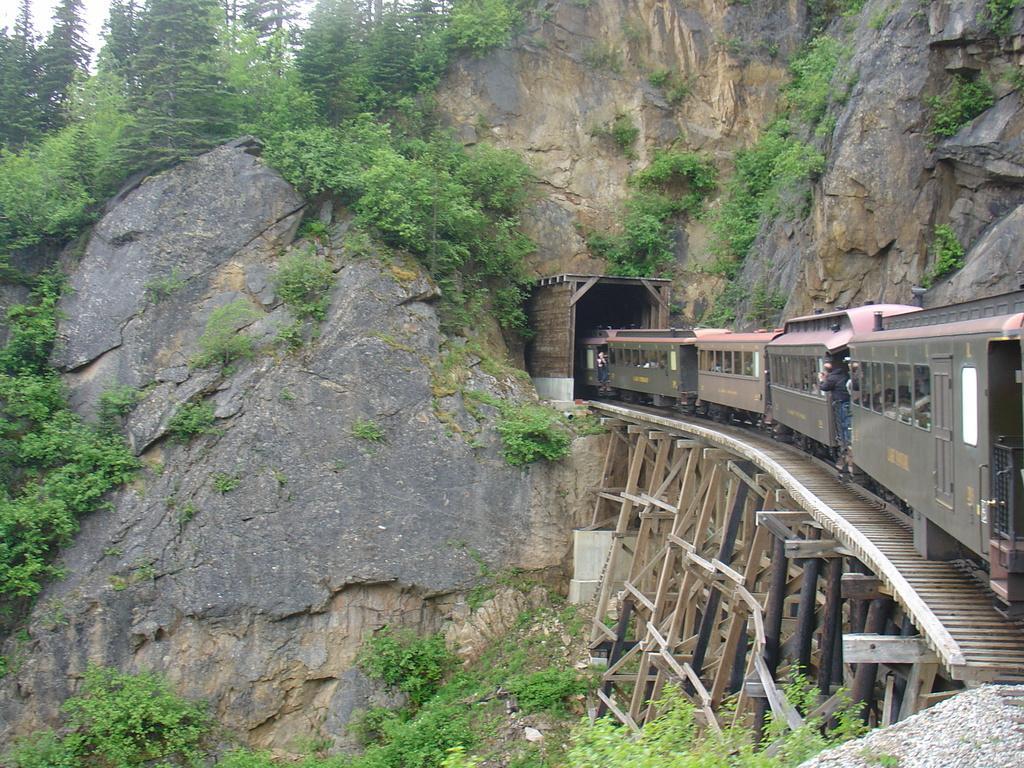Describe this image in one or two sentences. We can see train on track and we can see plants,trees and hill. 